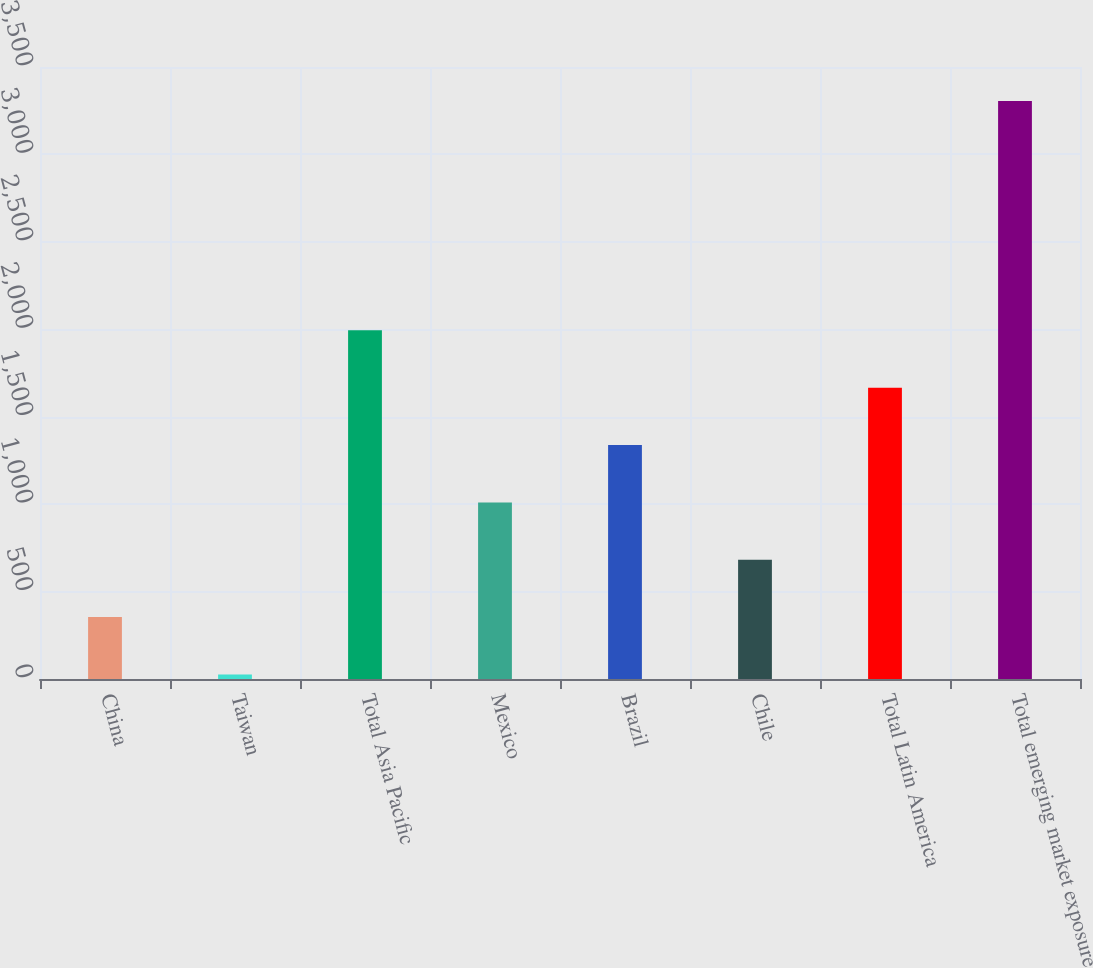Convert chart. <chart><loc_0><loc_0><loc_500><loc_500><bar_chart><fcel>China<fcel>Taiwan<fcel>Total Asia Pacific<fcel>Mexico<fcel>Brazil<fcel>Chile<fcel>Total Latin America<fcel>Total emerging market exposure<nl><fcel>354<fcel>26<fcel>1994<fcel>1010<fcel>1338<fcel>682<fcel>1666<fcel>3306<nl></chart> 